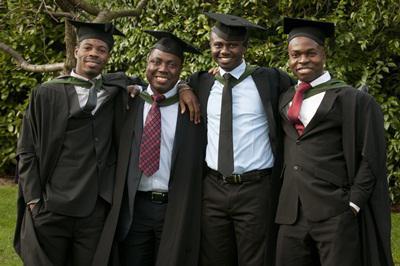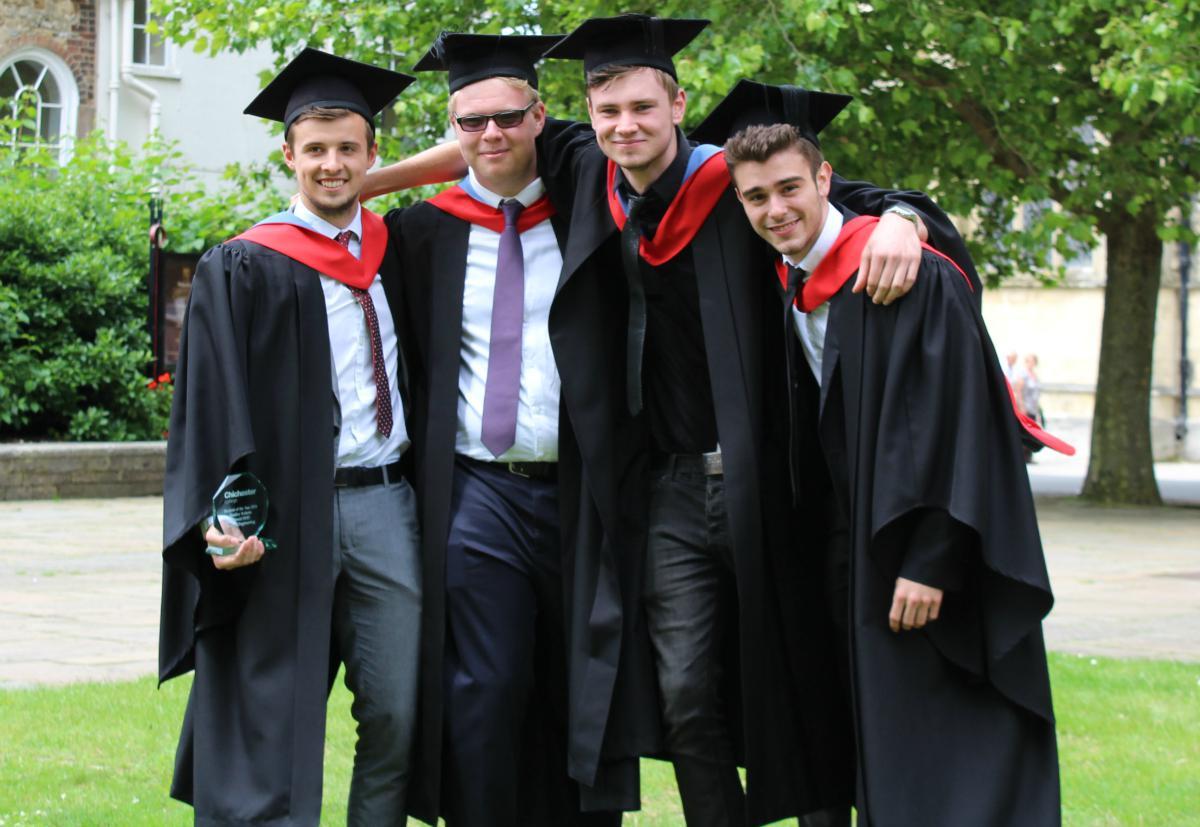The first image is the image on the left, the second image is the image on the right. Analyze the images presented: Is the assertion "A single graduate is posing wearing a blue outfit in the image on the right." valid? Answer yes or no. No. The first image is the image on the left, the second image is the image on the right. For the images shown, is this caption "Two college graduates wearing black gowns and mortarboards are the focus of one image, while a single male wearing a gown is the focus of the second image." true? Answer yes or no. No. 